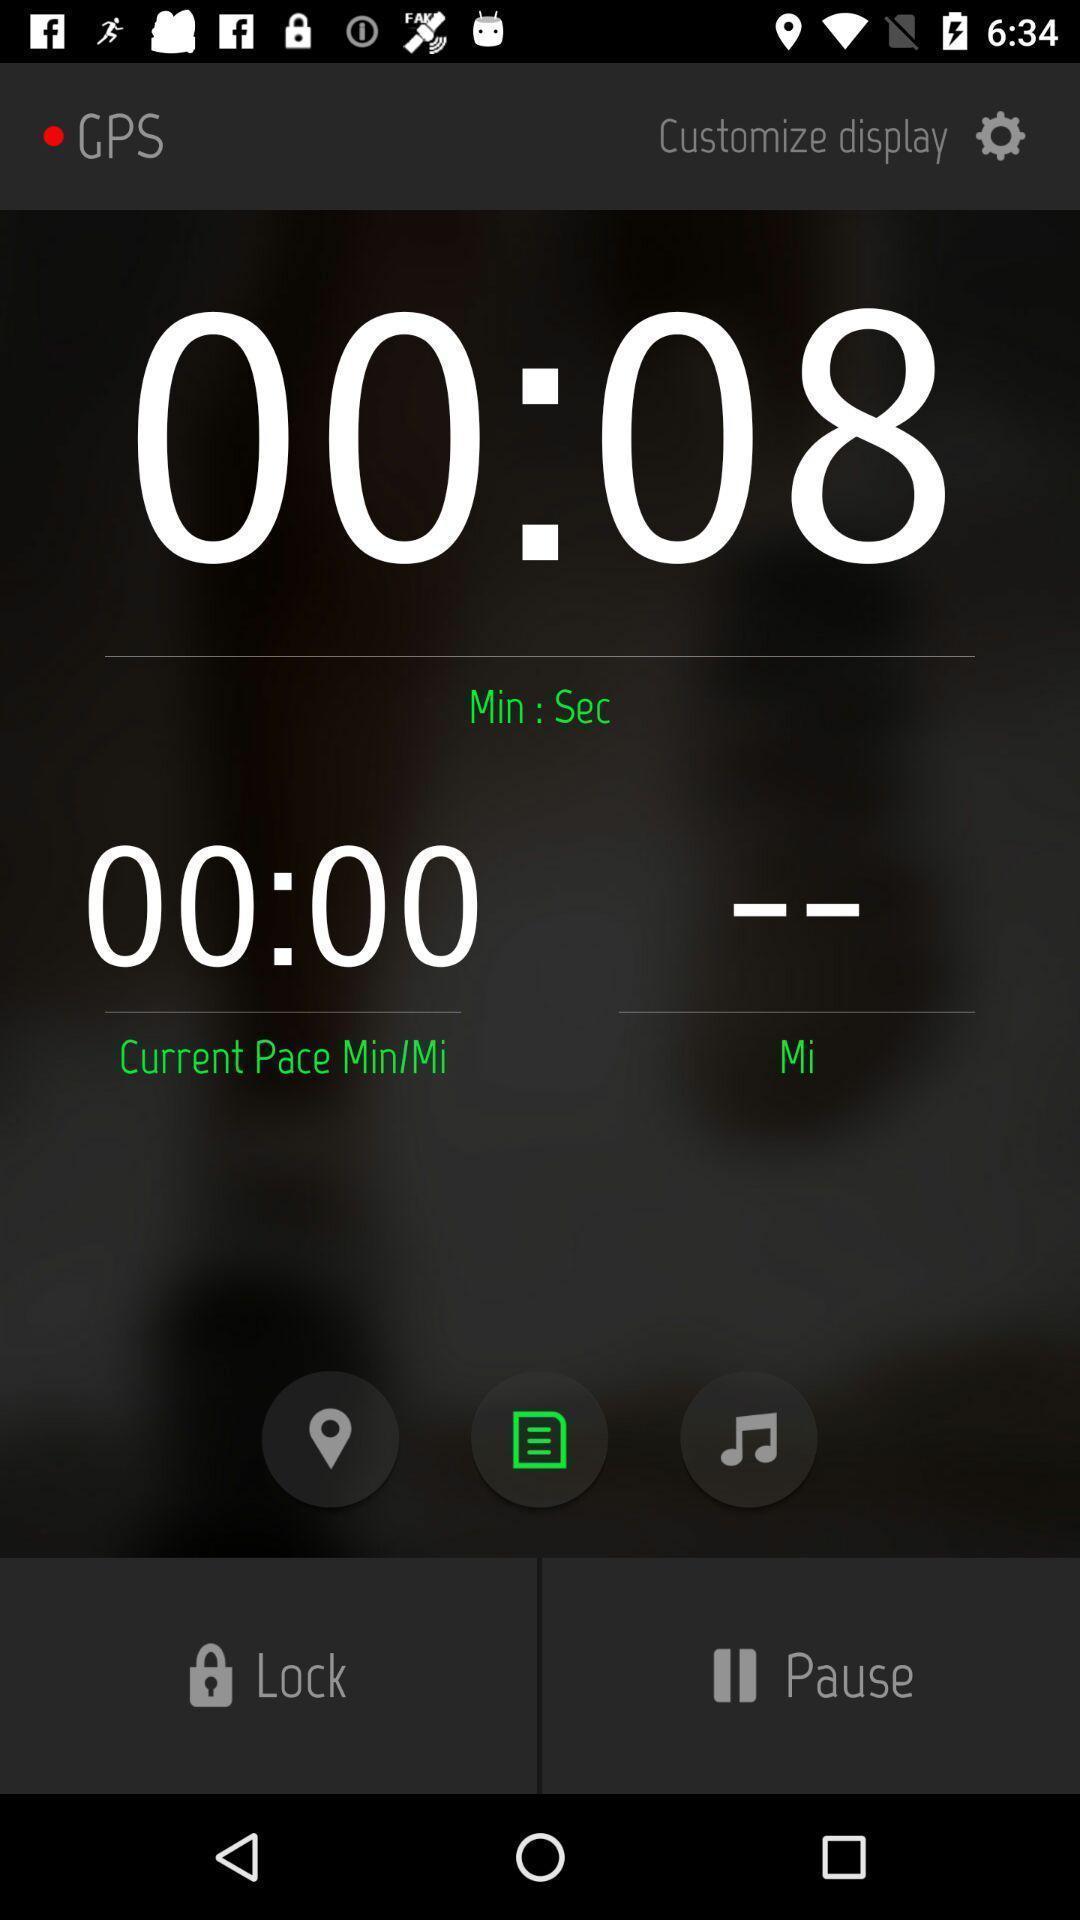Please provide a description for this image. Screen shows options in running tracker. 